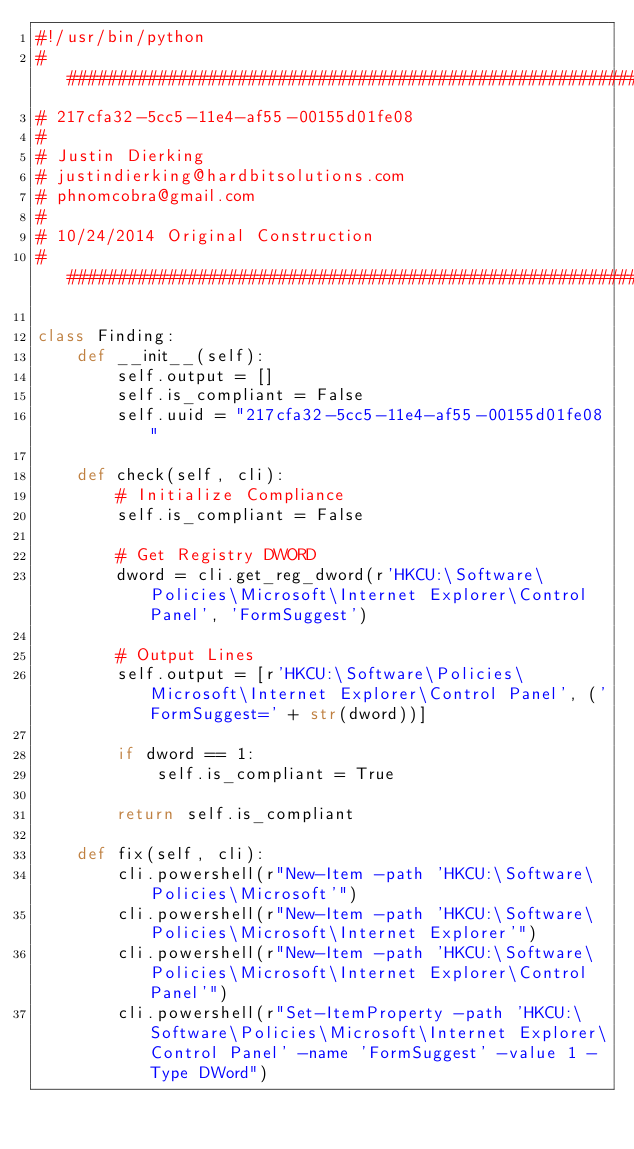Convert code to text. <code><loc_0><loc_0><loc_500><loc_500><_Python_>#!/usr/bin/python
################################################################################
# 217cfa32-5cc5-11e4-af55-00155d01fe08
#
# Justin Dierking
# justindierking@hardbitsolutions.com
# phnomcobra@gmail.com
#
# 10/24/2014 Original Construction
################################################################################

class Finding:
    def __init__(self):
        self.output = []
        self.is_compliant = False
        self.uuid = "217cfa32-5cc5-11e4-af55-00155d01fe08"
        
    def check(self, cli):
        # Initialize Compliance
        self.is_compliant = False

        # Get Registry DWORD
        dword = cli.get_reg_dword(r'HKCU:\Software\Policies\Microsoft\Internet Explorer\Control Panel', 'FormSuggest')

        # Output Lines
        self.output = [r'HKCU:\Software\Policies\Microsoft\Internet Explorer\Control Panel', ('FormSuggest=' + str(dword))]

        if dword == 1:
            self.is_compliant = True

        return self.is_compliant

    def fix(self, cli):
        cli.powershell(r"New-Item -path 'HKCU:\Software\Policies\Microsoft'")
        cli.powershell(r"New-Item -path 'HKCU:\Software\Policies\Microsoft\Internet Explorer'")
        cli.powershell(r"New-Item -path 'HKCU:\Software\Policies\Microsoft\Internet Explorer\Control Panel'")
        cli.powershell(r"Set-ItemProperty -path 'HKCU:\Software\Policies\Microsoft\Internet Explorer\Control Panel' -name 'FormSuggest' -value 1 -Type DWord")
</code> 